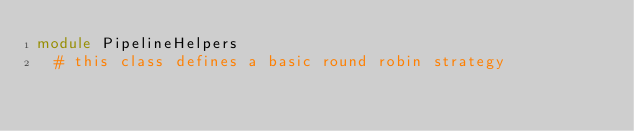<code> <loc_0><loc_0><loc_500><loc_500><_Ruby_>module PipelineHelpers
  # this class defines a basic round robin strategy</code> 